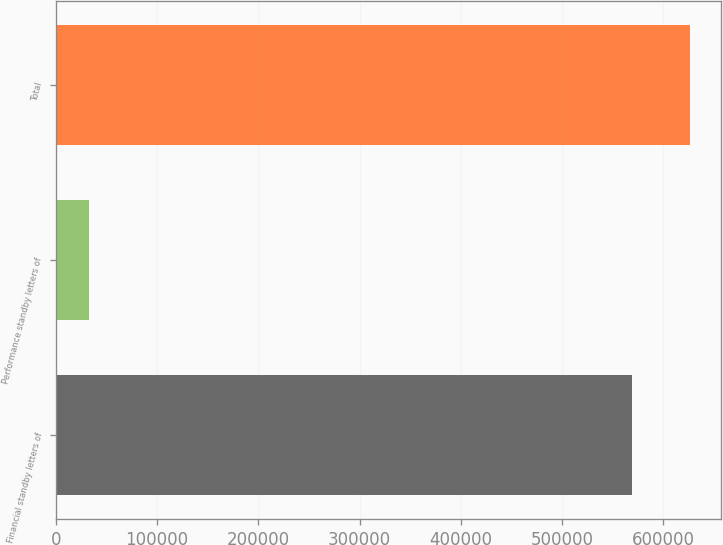Convert chart to OTSL. <chart><loc_0><loc_0><loc_500><loc_500><bar_chart><fcel>Financial standby letters of<fcel>Performance standby letters of<fcel>Total<nl><fcel>568797<fcel>32970<fcel>626099<nl></chart> 